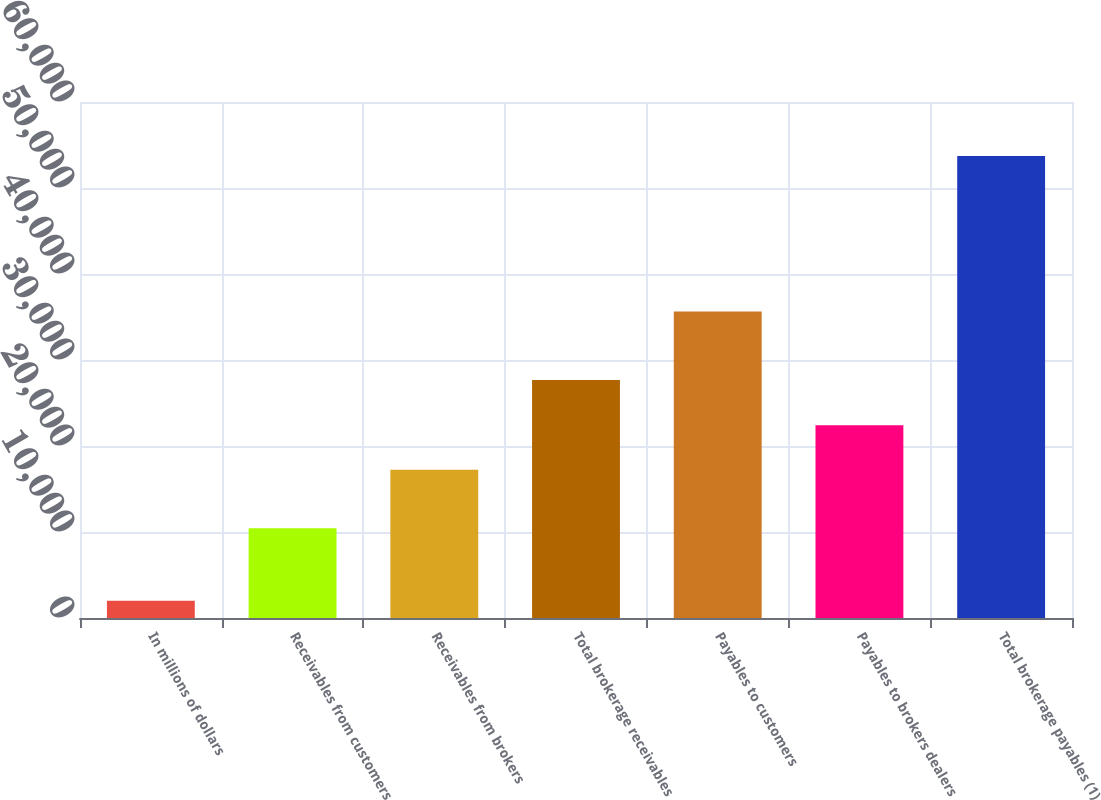Convert chart. <chart><loc_0><loc_0><loc_500><loc_500><bar_chart><fcel>In millions of dollars<fcel>Receivables from customers<fcel>Receivables from brokers<fcel>Total brokerage receivables<fcel>Payables to customers<fcel>Payables to brokers dealers<fcel>Total brokerage payables (1)<nl><fcel>2015<fcel>10435<fcel>17248<fcel>27683<fcel>35653<fcel>22418.7<fcel>53722<nl></chart> 